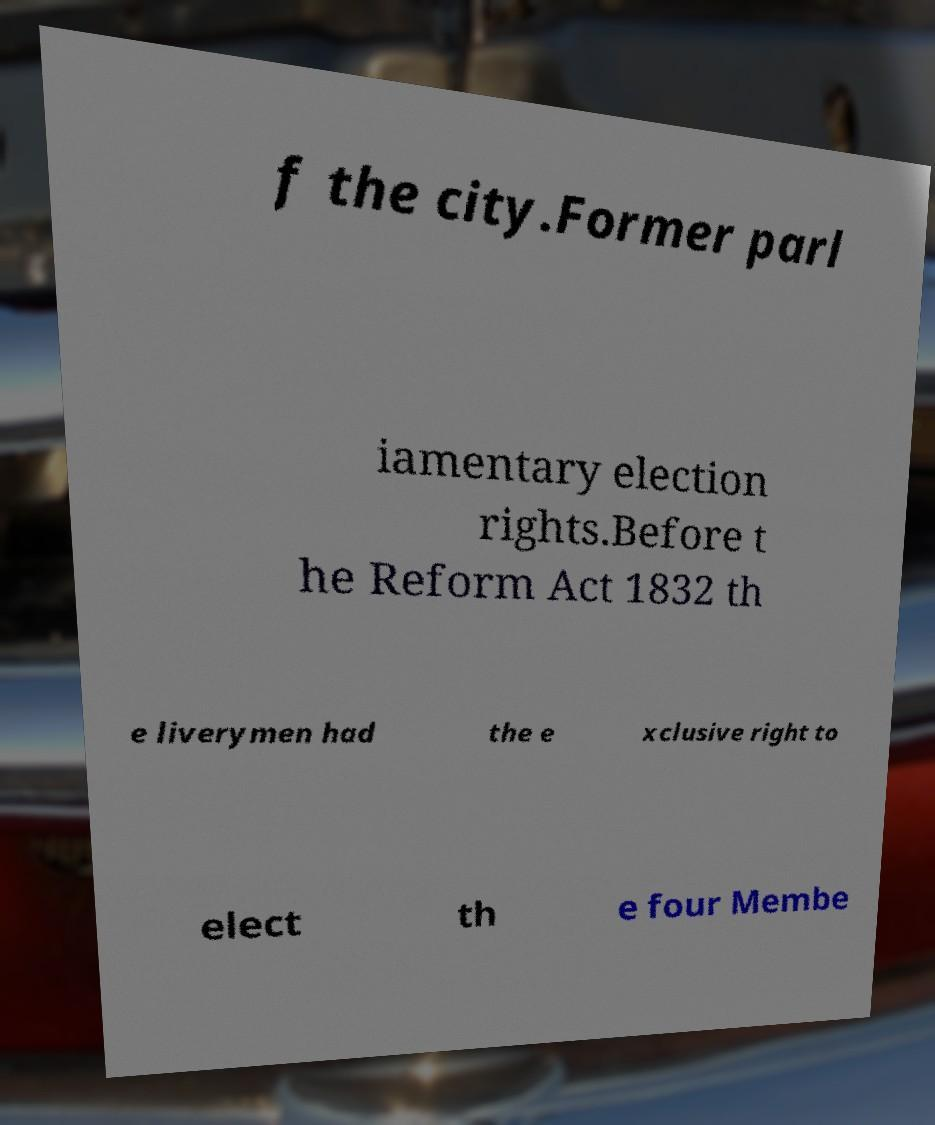Could you assist in decoding the text presented in this image and type it out clearly? f the city.Former parl iamentary election rights.Before t he Reform Act 1832 th e liverymen had the e xclusive right to elect th e four Membe 